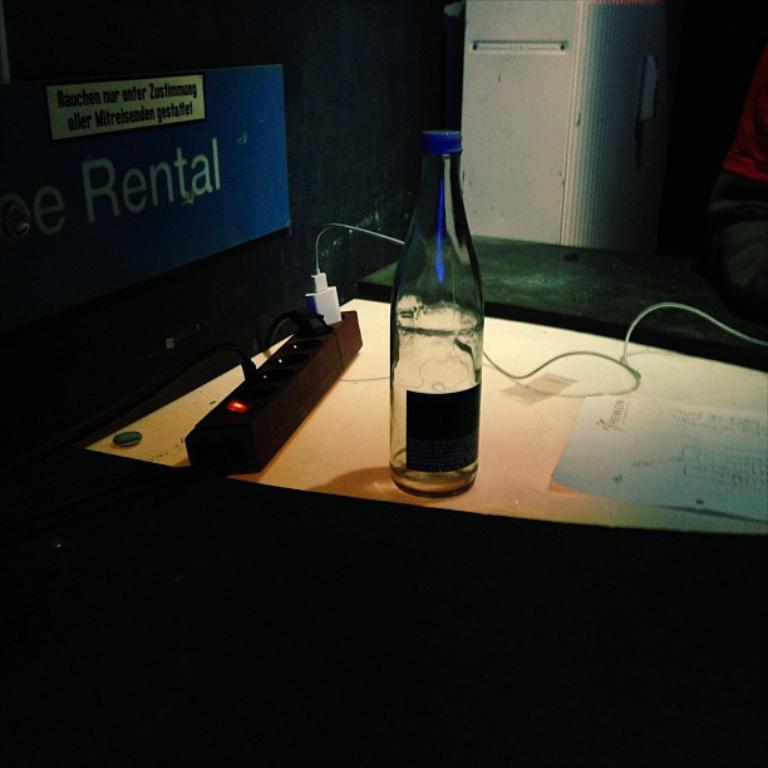Please provide a concise description of this image. This is the table with a bottle, paper and plug box on it. I can see a cable connected to the plug box. This looks like a board, which is attached to the wall. I think this is a white color object. At the right corner of the image, I can see a person sitting on the bench. 